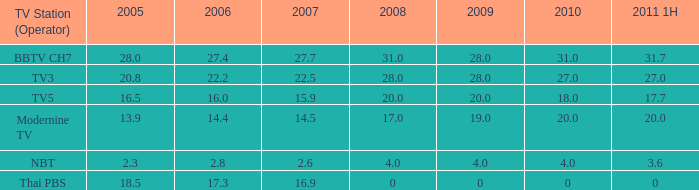What is the highest 2011 1H value for a 2005 over 28? None. 